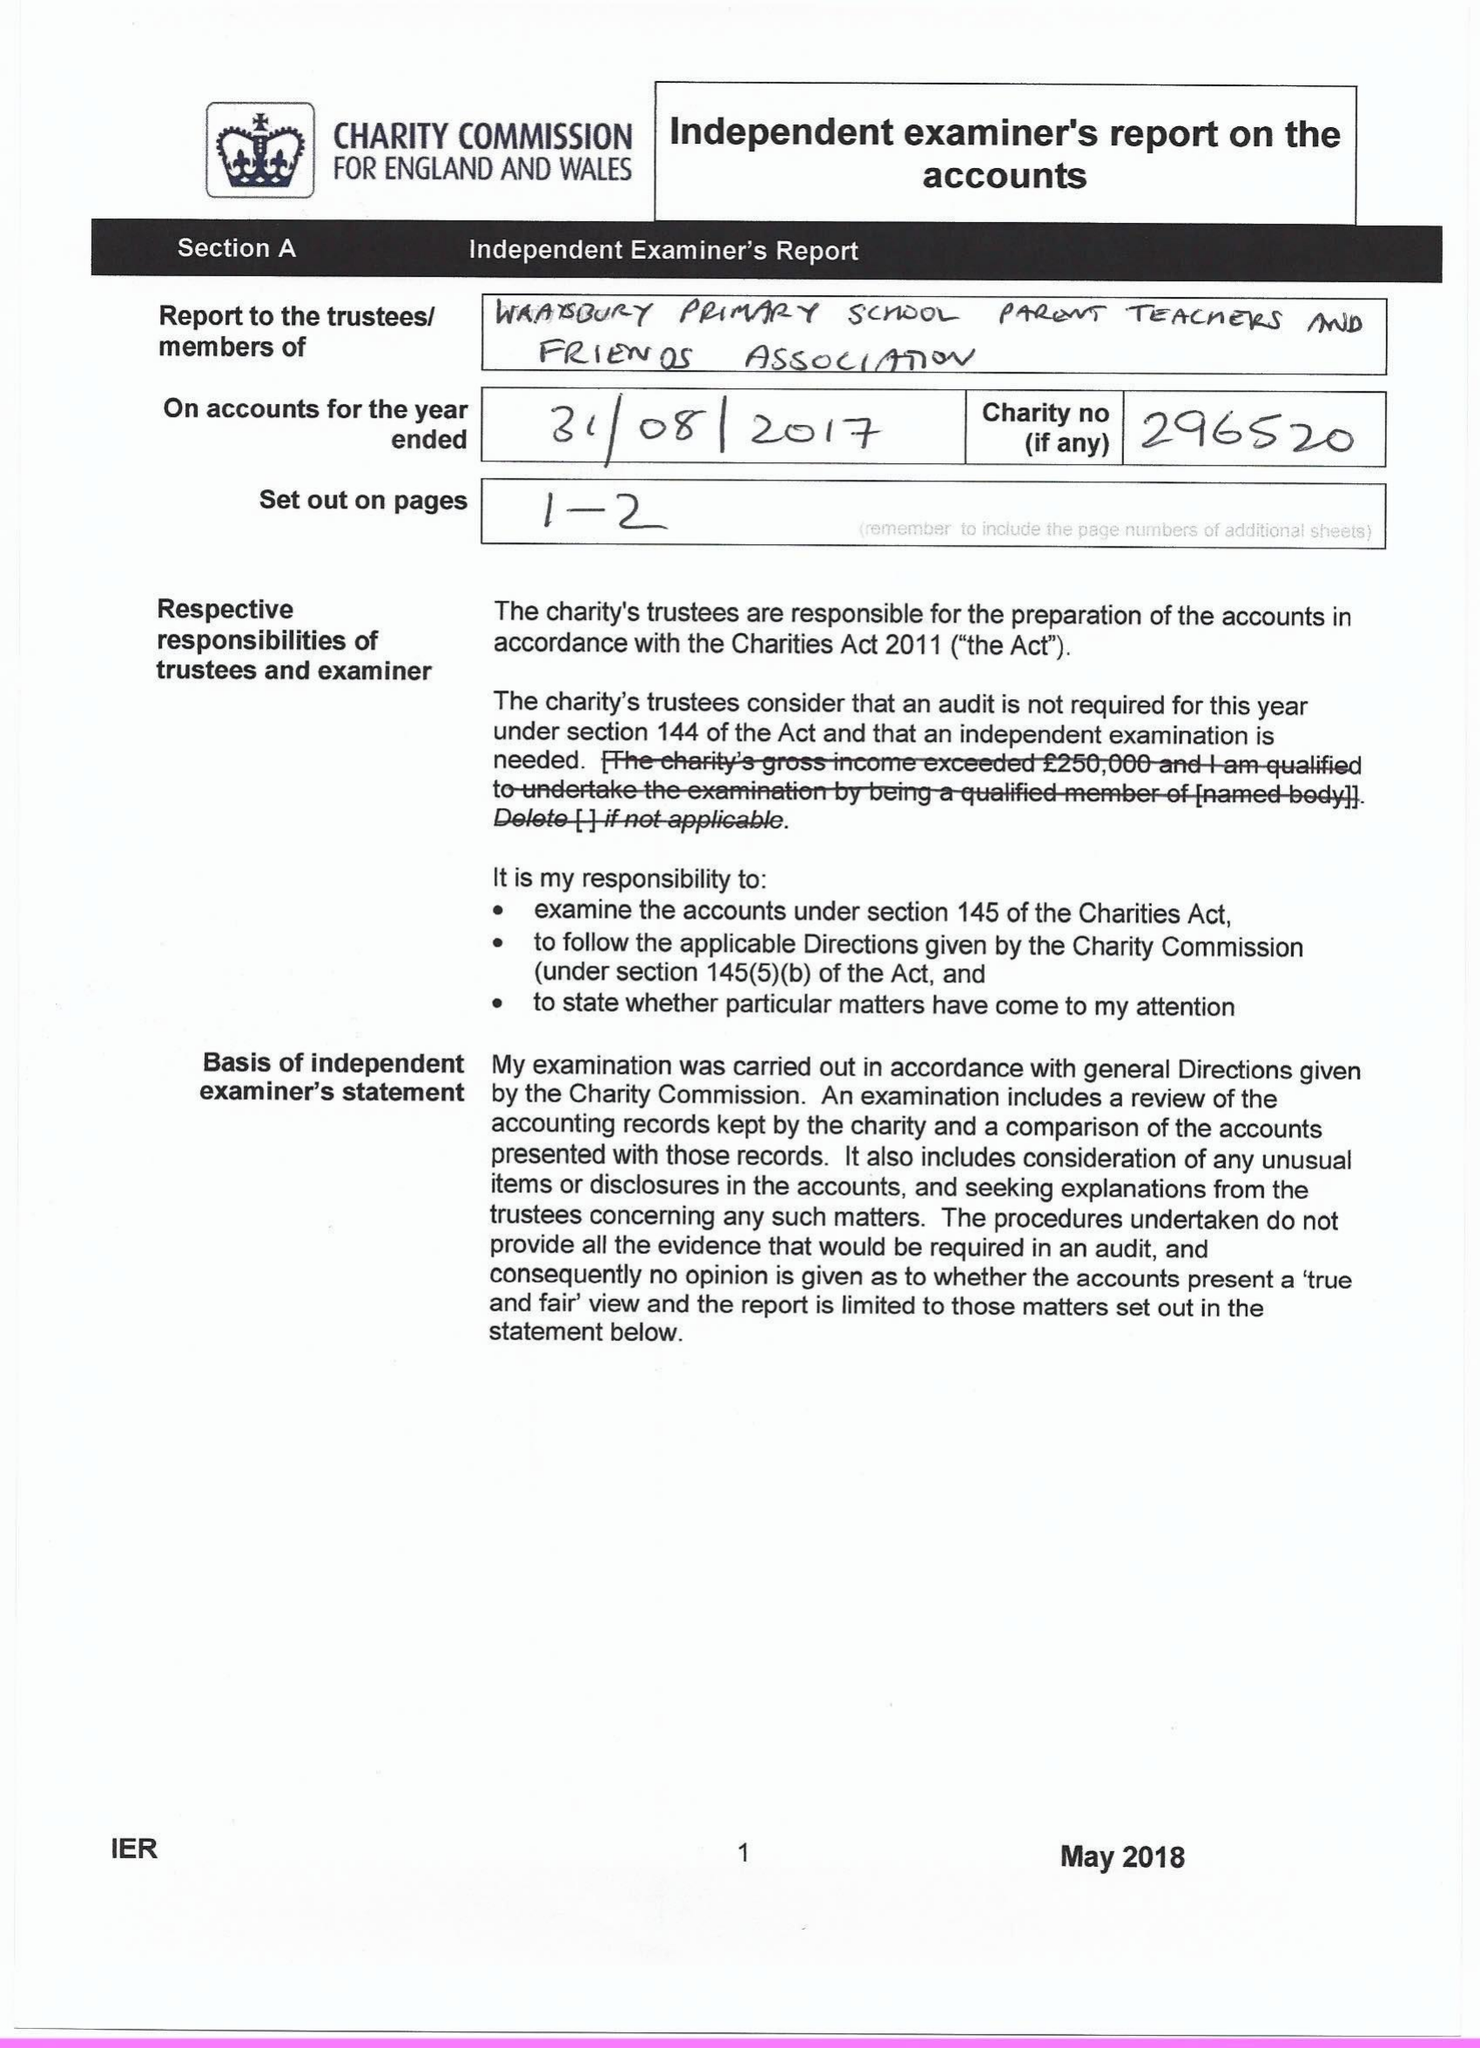What is the value for the address__street_line?
Answer the question using a single word or phrase. WELLEY ROAD 